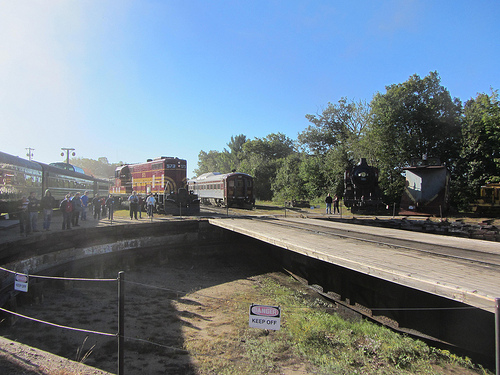Is the dirt below the platform the people are on? Yes, the platform that the people are standing on is above a dirt area. 